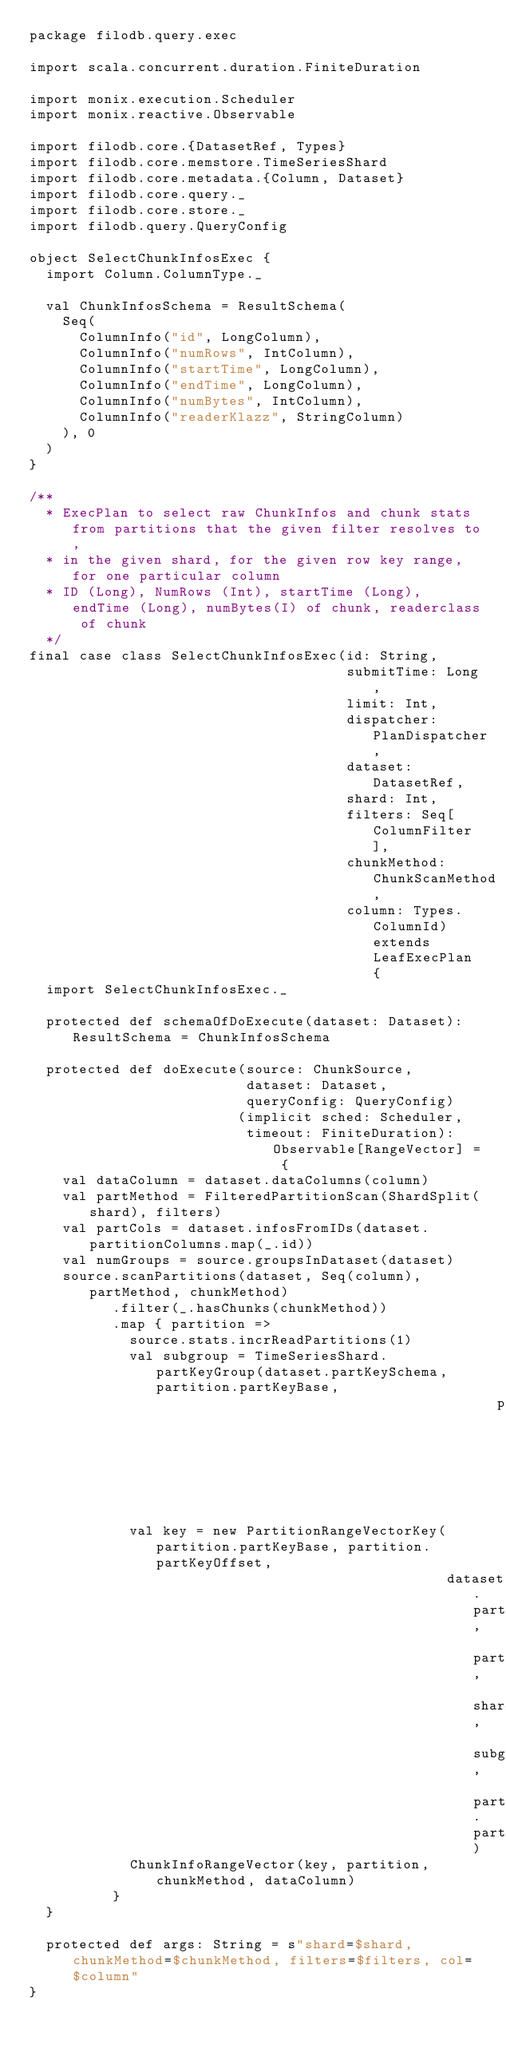<code> <loc_0><loc_0><loc_500><loc_500><_Scala_>package filodb.query.exec

import scala.concurrent.duration.FiniteDuration

import monix.execution.Scheduler
import monix.reactive.Observable

import filodb.core.{DatasetRef, Types}
import filodb.core.memstore.TimeSeriesShard
import filodb.core.metadata.{Column, Dataset}
import filodb.core.query._
import filodb.core.store._
import filodb.query.QueryConfig

object SelectChunkInfosExec {
  import Column.ColumnType._

  val ChunkInfosSchema = ResultSchema(
    Seq(
      ColumnInfo("id", LongColumn),
      ColumnInfo("numRows", IntColumn),
      ColumnInfo("startTime", LongColumn),
      ColumnInfo("endTime", LongColumn),
      ColumnInfo("numBytes", IntColumn),
      ColumnInfo("readerKlazz", StringColumn)
    ), 0
  )
}

/**
  * ExecPlan to select raw ChunkInfos and chunk stats from partitions that the given filter resolves to,
  * in the given shard, for the given row key range, for one particular column
  * ID (Long), NumRows (Int), startTime (Long), endTime (Long), numBytes(I) of chunk, readerclass of chunk
  */
final case class SelectChunkInfosExec(id: String,
                                      submitTime: Long,
                                      limit: Int,
                                      dispatcher: PlanDispatcher,
                                      dataset: DatasetRef,
                                      shard: Int,
                                      filters: Seq[ColumnFilter],
                                      chunkMethod: ChunkScanMethod,
                                      column: Types.ColumnId) extends LeafExecPlan {
  import SelectChunkInfosExec._

  protected def schemaOfDoExecute(dataset: Dataset): ResultSchema = ChunkInfosSchema

  protected def doExecute(source: ChunkSource,
                          dataset: Dataset,
                          queryConfig: QueryConfig)
                         (implicit sched: Scheduler,
                          timeout: FiniteDuration): Observable[RangeVector] = {
    val dataColumn = dataset.dataColumns(column)
    val partMethod = FilteredPartitionScan(ShardSplit(shard), filters)
    val partCols = dataset.infosFromIDs(dataset.partitionColumns.map(_.id))
    val numGroups = source.groupsInDataset(dataset)
    source.scanPartitions(dataset, Seq(column), partMethod, chunkMethod)
          .filter(_.hasChunks(chunkMethod))
          .map { partition =>
            source.stats.incrReadPartitions(1)
            val subgroup = TimeSeriesShard.partKeyGroup(dataset.partKeySchema, partition.partKeyBase,
                                                        partition.partKeyOffset, numGroups)
            val key = new PartitionRangeVectorKey(partition.partKeyBase, partition.partKeyOffset,
                                                  dataset.partKeySchema, partCols, shard, subgroup, partition.partID)
            ChunkInfoRangeVector(key, partition, chunkMethod, dataColumn)
          }
  }

  protected def args: String = s"shard=$shard, chunkMethod=$chunkMethod, filters=$filters, col=$column"
}

</code> 